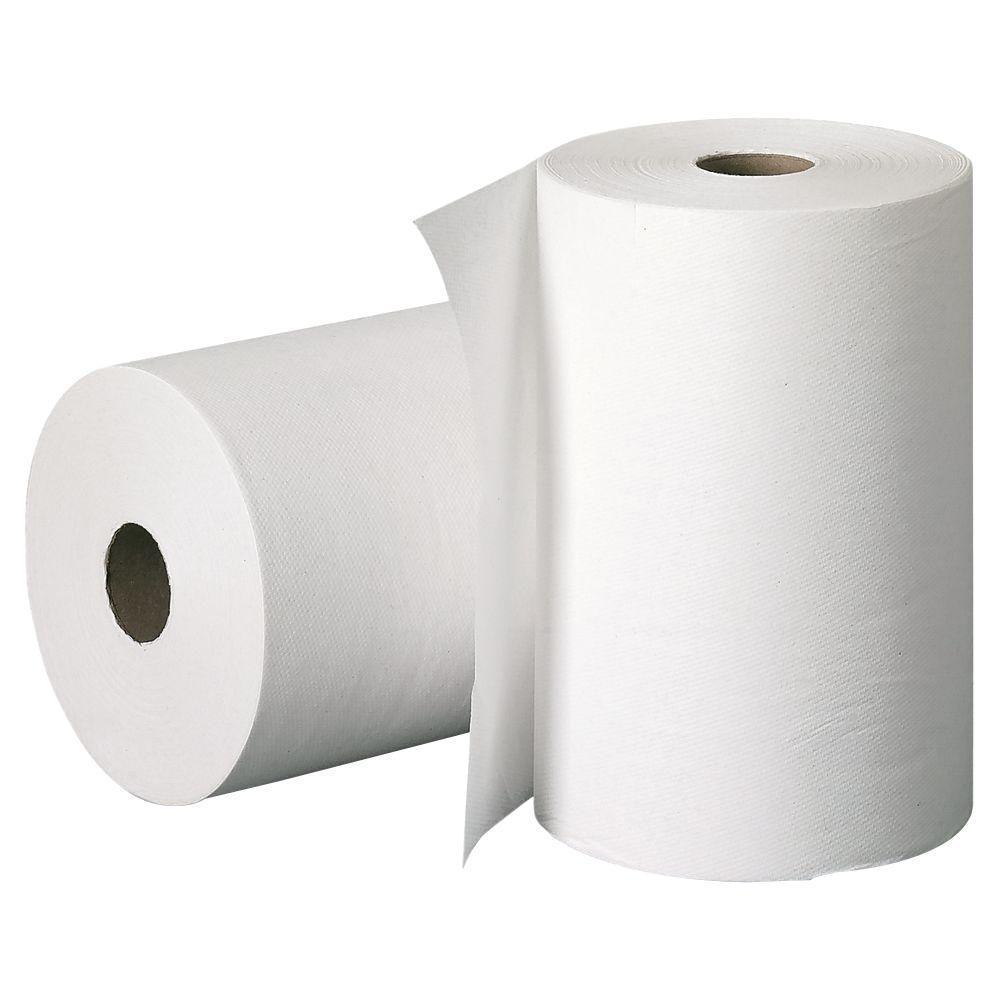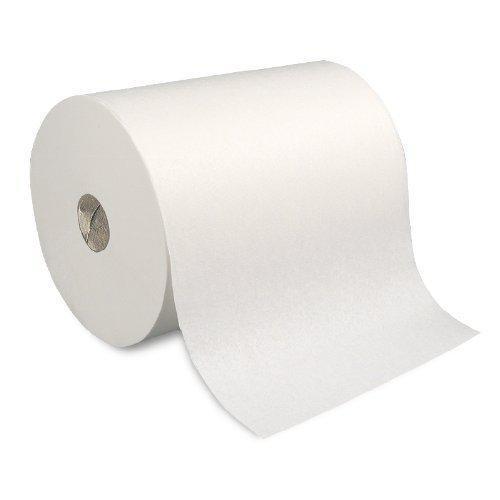The first image is the image on the left, the second image is the image on the right. For the images displayed, is the sentence "There are three rolls of paper towels." factually correct? Answer yes or no. Yes. 